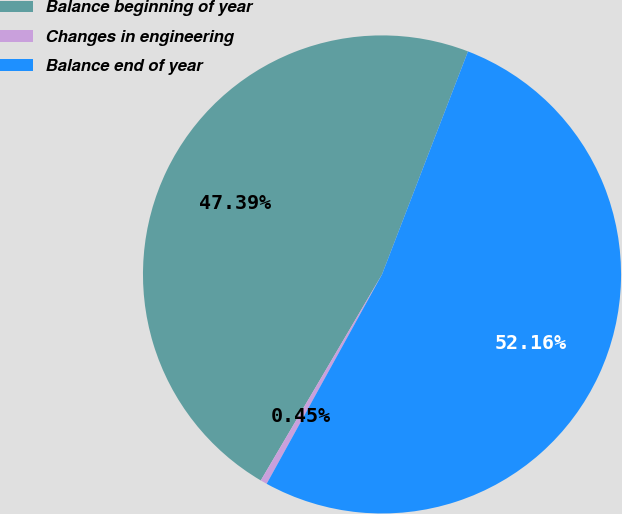Convert chart. <chart><loc_0><loc_0><loc_500><loc_500><pie_chart><fcel>Balance beginning of year<fcel>Changes in engineering<fcel>Balance end of year<nl><fcel>47.39%<fcel>0.45%<fcel>52.16%<nl></chart> 